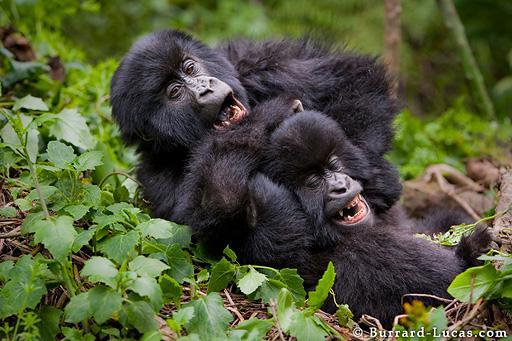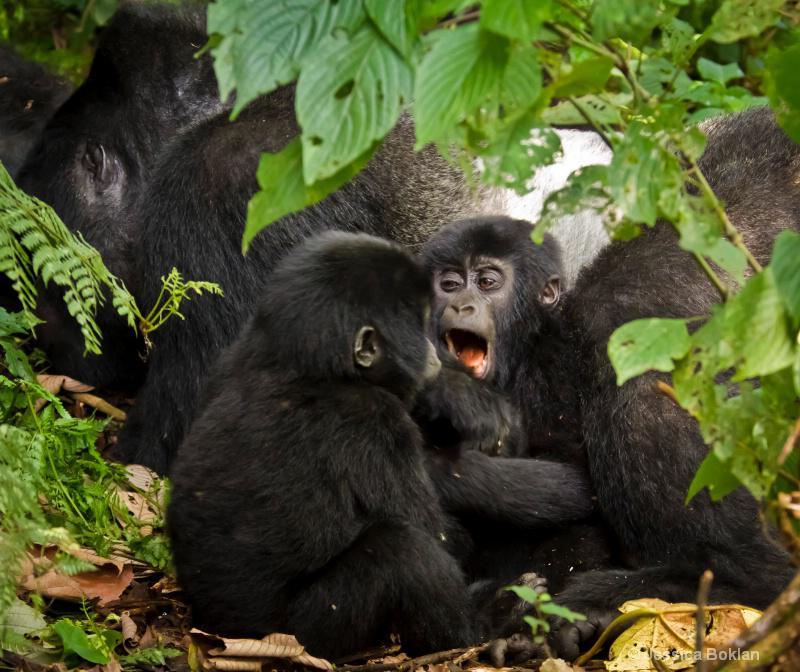The first image is the image on the left, the second image is the image on the right. Examine the images to the left and right. Is the description "One image shows two young gorillas playing on a tree branch, and one of them is climbing up the branch." accurate? Answer yes or no. No. The first image is the image on the left, the second image is the image on the right. For the images shown, is this caption "The left image contains no more than one gorilla." true? Answer yes or no. No. 